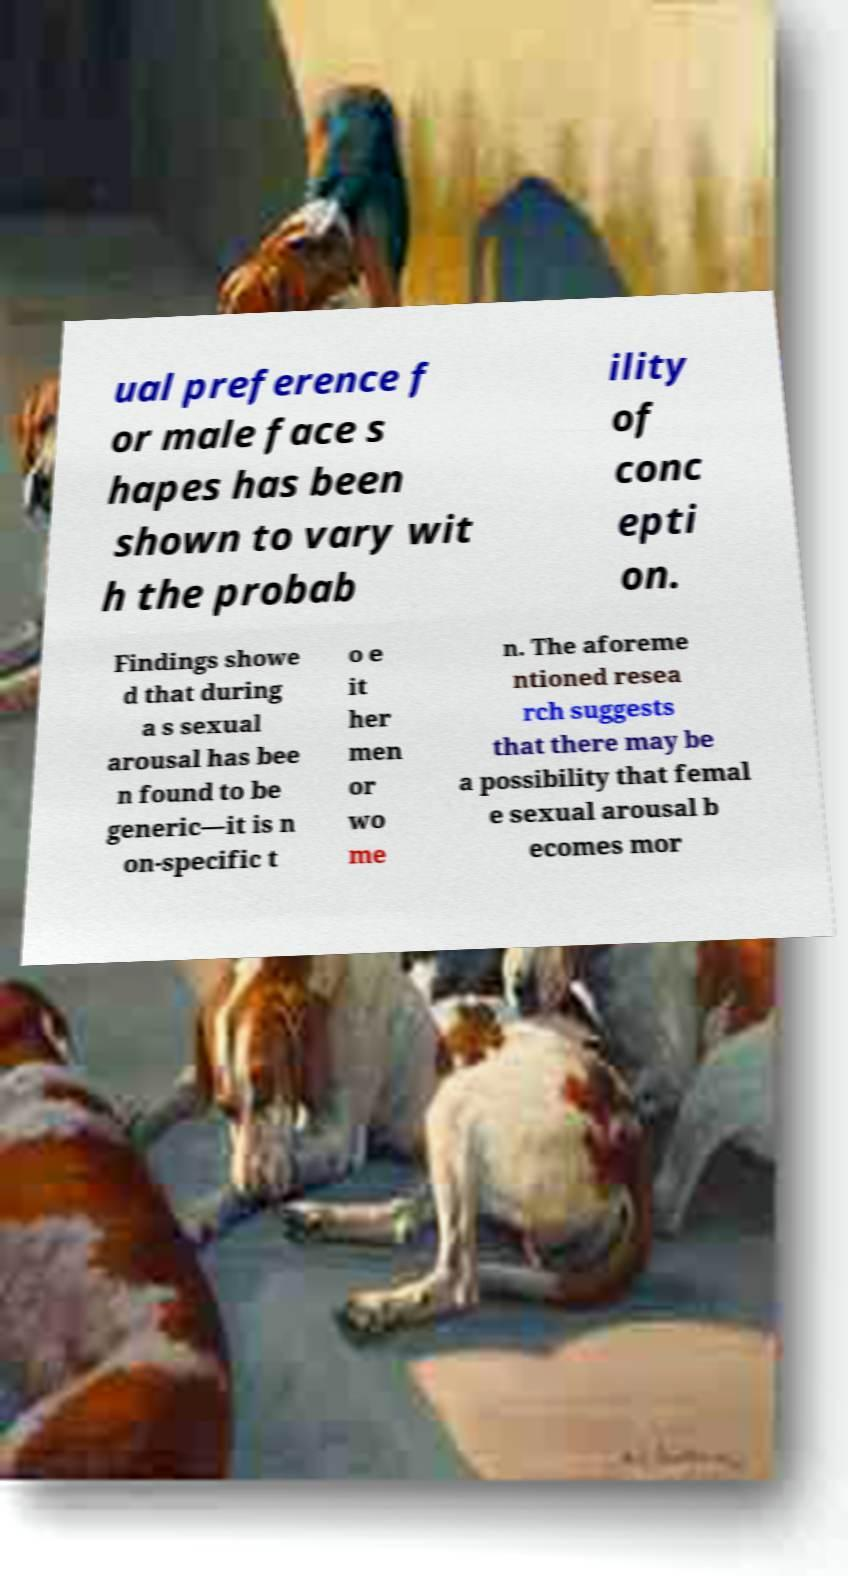I need the written content from this picture converted into text. Can you do that? ual preference f or male face s hapes has been shown to vary wit h the probab ility of conc epti on. Findings showe d that during a s sexual arousal has bee n found to be generic—it is n on-specific t o e it her men or wo me n. The aforeme ntioned resea rch suggests that there may be a possibility that femal e sexual arousal b ecomes mor 